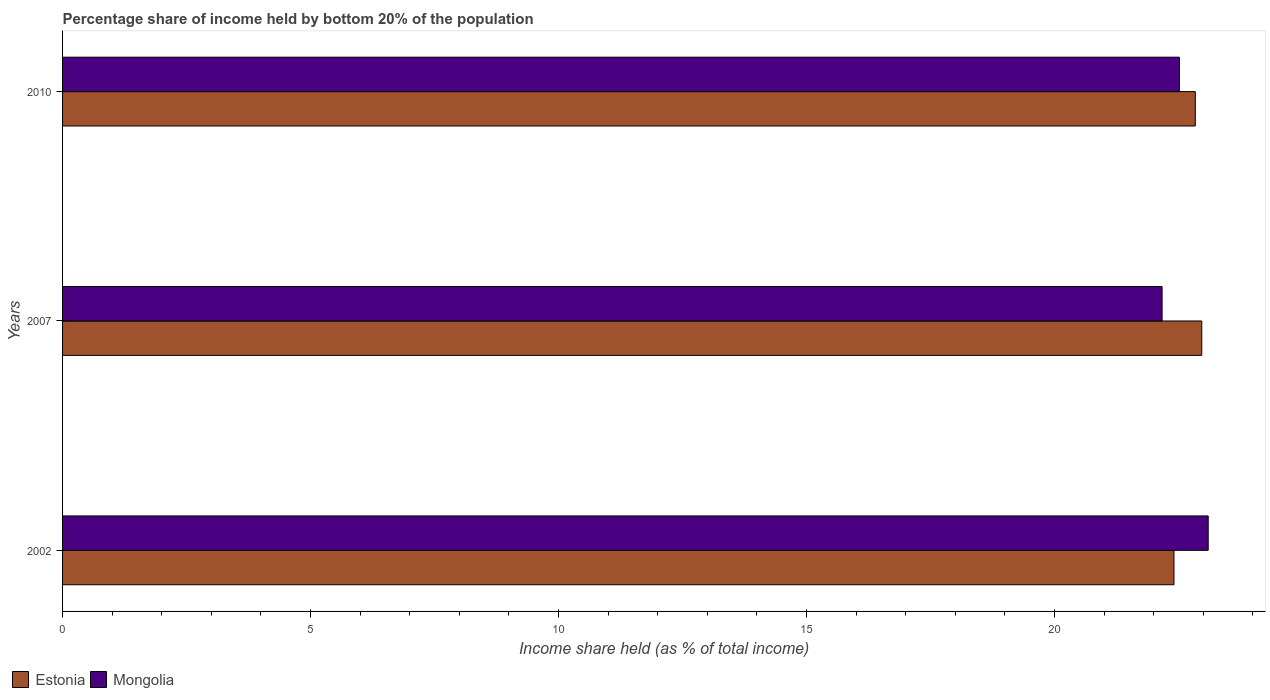How many different coloured bars are there?
Give a very brief answer. 2. Are the number of bars per tick equal to the number of legend labels?
Offer a very short reply. Yes. Are the number of bars on each tick of the Y-axis equal?
Provide a short and direct response. Yes. How many bars are there on the 2nd tick from the bottom?
Keep it short and to the point. 2. In how many cases, is the number of bars for a given year not equal to the number of legend labels?
Your response must be concise. 0. What is the share of income held by bottom 20% of the population in Estonia in 2007?
Your answer should be very brief. 22.97. Across all years, what is the maximum share of income held by bottom 20% of the population in Estonia?
Your answer should be very brief. 22.97. Across all years, what is the minimum share of income held by bottom 20% of the population in Mongolia?
Offer a terse response. 22.17. In which year was the share of income held by bottom 20% of the population in Mongolia maximum?
Your response must be concise. 2002. What is the total share of income held by bottom 20% of the population in Mongolia in the graph?
Provide a succinct answer. 67.79. What is the difference between the share of income held by bottom 20% of the population in Estonia in 2002 and that in 2007?
Your answer should be very brief. -0.56. What is the difference between the share of income held by bottom 20% of the population in Mongolia in 2010 and the share of income held by bottom 20% of the population in Estonia in 2007?
Your answer should be very brief. -0.45. What is the average share of income held by bottom 20% of the population in Mongolia per year?
Make the answer very short. 22.6. In the year 2010, what is the difference between the share of income held by bottom 20% of the population in Estonia and share of income held by bottom 20% of the population in Mongolia?
Your answer should be very brief. 0.32. In how many years, is the share of income held by bottom 20% of the population in Estonia greater than 23 %?
Ensure brevity in your answer.  0. What is the ratio of the share of income held by bottom 20% of the population in Mongolia in 2007 to that in 2010?
Your answer should be very brief. 0.98. What is the difference between the highest and the second highest share of income held by bottom 20% of the population in Mongolia?
Keep it short and to the point. 0.58. What is the difference between the highest and the lowest share of income held by bottom 20% of the population in Estonia?
Offer a terse response. 0.56. In how many years, is the share of income held by bottom 20% of the population in Mongolia greater than the average share of income held by bottom 20% of the population in Mongolia taken over all years?
Keep it short and to the point. 1. What does the 1st bar from the top in 2002 represents?
Give a very brief answer. Mongolia. What does the 2nd bar from the bottom in 2002 represents?
Provide a short and direct response. Mongolia. Are all the bars in the graph horizontal?
Make the answer very short. Yes. What is the difference between two consecutive major ticks on the X-axis?
Provide a succinct answer. 5. Does the graph contain grids?
Provide a succinct answer. No. How many legend labels are there?
Make the answer very short. 2. How are the legend labels stacked?
Keep it short and to the point. Horizontal. What is the title of the graph?
Offer a terse response. Percentage share of income held by bottom 20% of the population. What is the label or title of the X-axis?
Your response must be concise. Income share held (as % of total income). What is the Income share held (as % of total income) of Estonia in 2002?
Provide a short and direct response. 22.41. What is the Income share held (as % of total income) of Mongolia in 2002?
Keep it short and to the point. 23.1. What is the Income share held (as % of total income) in Estonia in 2007?
Give a very brief answer. 22.97. What is the Income share held (as % of total income) in Mongolia in 2007?
Offer a very short reply. 22.17. What is the Income share held (as % of total income) of Estonia in 2010?
Your answer should be compact. 22.84. What is the Income share held (as % of total income) of Mongolia in 2010?
Offer a terse response. 22.52. Across all years, what is the maximum Income share held (as % of total income) in Estonia?
Provide a succinct answer. 22.97. Across all years, what is the maximum Income share held (as % of total income) of Mongolia?
Your response must be concise. 23.1. Across all years, what is the minimum Income share held (as % of total income) of Estonia?
Provide a succinct answer. 22.41. Across all years, what is the minimum Income share held (as % of total income) in Mongolia?
Give a very brief answer. 22.17. What is the total Income share held (as % of total income) of Estonia in the graph?
Your response must be concise. 68.22. What is the total Income share held (as % of total income) in Mongolia in the graph?
Your response must be concise. 67.79. What is the difference between the Income share held (as % of total income) of Estonia in 2002 and that in 2007?
Your answer should be very brief. -0.56. What is the difference between the Income share held (as % of total income) in Mongolia in 2002 and that in 2007?
Offer a very short reply. 0.93. What is the difference between the Income share held (as % of total income) in Estonia in 2002 and that in 2010?
Provide a succinct answer. -0.43. What is the difference between the Income share held (as % of total income) of Mongolia in 2002 and that in 2010?
Make the answer very short. 0.58. What is the difference between the Income share held (as % of total income) in Estonia in 2007 and that in 2010?
Offer a terse response. 0.13. What is the difference between the Income share held (as % of total income) in Mongolia in 2007 and that in 2010?
Offer a very short reply. -0.35. What is the difference between the Income share held (as % of total income) in Estonia in 2002 and the Income share held (as % of total income) in Mongolia in 2007?
Offer a very short reply. 0.24. What is the difference between the Income share held (as % of total income) in Estonia in 2002 and the Income share held (as % of total income) in Mongolia in 2010?
Provide a succinct answer. -0.11. What is the difference between the Income share held (as % of total income) of Estonia in 2007 and the Income share held (as % of total income) of Mongolia in 2010?
Provide a succinct answer. 0.45. What is the average Income share held (as % of total income) in Estonia per year?
Provide a succinct answer. 22.74. What is the average Income share held (as % of total income) of Mongolia per year?
Give a very brief answer. 22.6. In the year 2002, what is the difference between the Income share held (as % of total income) in Estonia and Income share held (as % of total income) in Mongolia?
Offer a very short reply. -0.69. In the year 2007, what is the difference between the Income share held (as % of total income) of Estonia and Income share held (as % of total income) of Mongolia?
Offer a very short reply. 0.8. In the year 2010, what is the difference between the Income share held (as % of total income) in Estonia and Income share held (as % of total income) in Mongolia?
Your response must be concise. 0.32. What is the ratio of the Income share held (as % of total income) in Estonia in 2002 to that in 2007?
Offer a very short reply. 0.98. What is the ratio of the Income share held (as % of total income) in Mongolia in 2002 to that in 2007?
Make the answer very short. 1.04. What is the ratio of the Income share held (as % of total income) in Estonia in 2002 to that in 2010?
Provide a succinct answer. 0.98. What is the ratio of the Income share held (as % of total income) of Mongolia in 2002 to that in 2010?
Offer a terse response. 1.03. What is the ratio of the Income share held (as % of total income) of Estonia in 2007 to that in 2010?
Ensure brevity in your answer.  1.01. What is the ratio of the Income share held (as % of total income) of Mongolia in 2007 to that in 2010?
Your answer should be very brief. 0.98. What is the difference between the highest and the second highest Income share held (as % of total income) in Estonia?
Offer a terse response. 0.13. What is the difference between the highest and the second highest Income share held (as % of total income) of Mongolia?
Give a very brief answer. 0.58. What is the difference between the highest and the lowest Income share held (as % of total income) of Estonia?
Give a very brief answer. 0.56. 